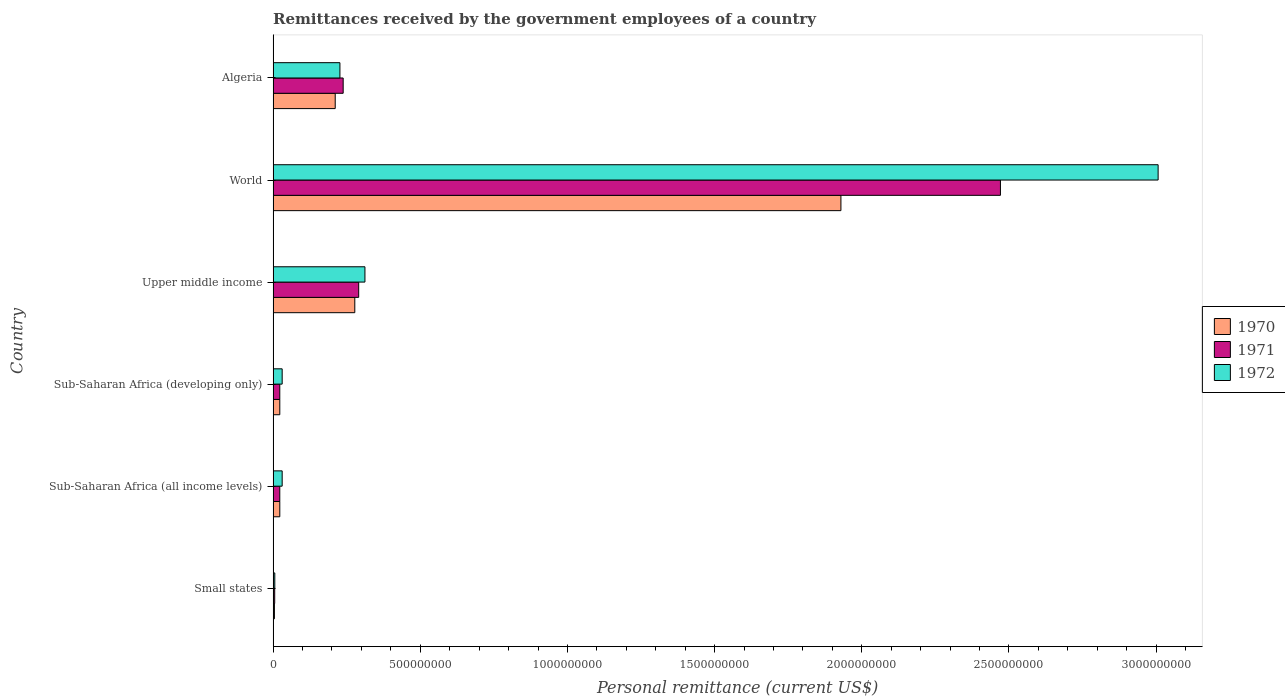How many different coloured bars are there?
Your response must be concise. 3. How many bars are there on the 5th tick from the top?
Provide a succinct answer. 3. What is the label of the 3rd group of bars from the top?
Your response must be concise. Upper middle income. In how many cases, is the number of bars for a given country not equal to the number of legend labels?
Your response must be concise. 0. What is the remittances received by the government employees in 1971 in Small states?
Keep it short and to the point. 5.40e+06. Across all countries, what is the maximum remittances received by the government employees in 1970?
Provide a succinct answer. 1.93e+09. Across all countries, what is the minimum remittances received by the government employees in 1972?
Ensure brevity in your answer.  5.71e+06. In which country was the remittances received by the government employees in 1971 minimum?
Offer a terse response. Small states. What is the total remittances received by the government employees in 1971 in the graph?
Offer a terse response. 3.05e+09. What is the difference between the remittances received by the government employees in 1970 in Algeria and that in World?
Your response must be concise. -1.72e+09. What is the difference between the remittances received by the government employees in 1970 in Algeria and the remittances received by the government employees in 1971 in Sub-Saharan Africa (all income levels)?
Ensure brevity in your answer.  1.88e+08. What is the average remittances received by the government employees in 1971 per country?
Your answer should be compact. 5.08e+08. What is the difference between the remittances received by the government employees in 1972 and remittances received by the government employees in 1970 in World?
Your response must be concise. 1.08e+09. What is the ratio of the remittances received by the government employees in 1970 in Sub-Saharan Africa (developing only) to that in World?
Make the answer very short. 0.01. What is the difference between the highest and the second highest remittances received by the government employees in 1971?
Provide a succinct answer. 2.18e+09. What is the difference between the highest and the lowest remittances received by the government employees in 1971?
Offer a very short reply. 2.47e+09. In how many countries, is the remittances received by the government employees in 1970 greater than the average remittances received by the government employees in 1970 taken over all countries?
Provide a succinct answer. 1. Is the sum of the remittances received by the government employees in 1972 in Sub-Saharan Africa (all income levels) and Upper middle income greater than the maximum remittances received by the government employees in 1971 across all countries?
Your answer should be compact. No. What does the 2nd bar from the bottom in Sub-Saharan Africa (all income levels) represents?
Keep it short and to the point. 1971. Is it the case that in every country, the sum of the remittances received by the government employees in 1971 and remittances received by the government employees in 1972 is greater than the remittances received by the government employees in 1970?
Keep it short and to the point. Yes. How many bars are there?
Provide a succinct answer. 18. Are all the bars in the graph horizontal?
Provide a succinct answer. Yes. What is the difference between two consecutive major ticks on the X-axis?
Make the answer very short. 5.00e+08. Does the graph contain any zero values?
Make the answer very short. No. Does the graph contain grids?
Ensure brevity in your answer.  No. Where does the legend appear in the graph?
Your response must be concise. Center right. How many legend labels are there?
Keep it short and to the point. 3. What is the title of the graph?
Ensure brevity in your answer.  Remittances received by the government employees of a country. What is the label or title of the X-axis?
Ensure brevity in your answer.  Personal remittance (current US$). What is the Personal remittance (current US$) in 1970 in Small states?
Offer a very short reply. 4.40e+06. What is the Personal remittance (current US$) in 1971 in Small states?
Make the answer very short. 5.40e+06. What is the Personal remittance (current US$) in 1972 in Small states?
Your response must be concise. 5.71e+06. What is the Personal remittance (current US$) of 1970 in Sub-Saharan Africa (all income levels)?
Keep it short and to the point. 2.27e+07. What is the Personal remittance (current US$) of 1971 in Sub-Saharan Africa (all income levels)?
Your response must be concise. 2.26e+07. What is the Personal remittance (current US$) of 1972 in Sub-Saharan Africa (all income levels)?
Your answer should be compact. 3.07e+07. What is the Personal remittance (current US$) in 1970 in Sub-Saharan Africa (developing only)?
Provide a succinct answer. 2.27e+07. What is the Personal remittance (current US$) of 1971 in Sub-Saharan Africa (developing only)?
Provide a succinct answer. 2.26e+07. What is the Personal remittance (current US$) in 1972 in Sub-Saharan Africa (developing only)?
Offer a very short reply. 3.07e+07. What is the Personal remittance (current US$) in 1970 in Upper middle income?
Provide a succinct answer. 2.77e+08. What is the Personal remittance (current US$) of 1971 in Upper middle income?
Ensure brevity in your answer.  2.91e+08. What is the Personal remittance (current US$) of 1972 in Upper middle income?
Your response must be concise. 3.12e+08. What is the Personal remittance (current US$) of 1970 in World?
Your answer should be compact. 1.93e+09. What is the Personal remittance (current US$) of 1971 in World?
Your answer should be very brief. 2.47e+09. What is the Personal remittance (current US$) in 1972 in World?
Make the answer very short. 3.01e+09. What is the Personal remittance (current US$) of 1970 in Algeria?
Keep it short and to the point. 2.11e+08. What is the Personal remittance (current US$) of 1971 in Algeria?
Offer a terse response. 2.38e+08. What is the Personal remittance (current US$) in 1972 in Algeria?
Provide a succinct answer. 2.27e+08. Across all countries, what is the maximum Personal remittance (current US$) of 1970?
Offer a terse response. 1.93e+09. Across all countries, what is the maximum Personal remittance (current US$) in 1971?
Your response must be concise. 2.47e+09. Across all countries, what is the maximum Personal remittance (current US$) of 1972?
Offer a terse response. 3.01e+09. Across all countries, what is the minimum Personal remittance (current US$) of 1970?
Offer a very short reply. 4.40e+06. Across all countries, what is the minimum Personal remittance (current US$) in 1971?
Keep it short and to the point. 5.40e+06. Across all countries, what is the minimum Personal remittance (current US$) in 1972?
Make the answer very short. 5.71e+06. What is the total Personal remittance (current US$) of 1970 in the graph?
Your answer should be very brief. 2.47e+09. What is the total Personal remittance (current US$) of 1971 in the graph?
Keep it short and to the point. 3.05e+09. What is the total Personal remittance (current US$) of 1972 in the graph?
Offer a very short reply. 3.61e+09. What is the difference between the Personal remittance (current US$) of 1970 in Small states and that in Sub-Saharan Africa (all income levels)?
Your answer should be compact. -1.83e+07. What is the difference between the Personal remittance (current US$) of 1971 in Small states and that in Sub-Saharan Africa (all income levels)?
Your answer should be very brief. -1.72e+07. What is the difference between the Personal remittance (current US$) in 1972 in Small states and that in Sub-Saharan Africa (all income levels)?
Offer a terse response. -2.50e+07. What is the difference between the Personal remittance (current US$) of 1970 in Small states and that in Sub-Saharan Africa (developing only)?
Give a very brief answer. -1.83e+07. What is the difference between the Personal remittance (current US$) in 1971 in Small states and that in Sub-Saharan Africa (developing only)?
Your response must be concise. -1.72e+07. What is the difference between the Personal remittance (current US$) of 1972 in Small states and that in Sub-Saharan Africa (developing only)?
Your answer should be very brief. -2.50e+07. What is the difference between the Personal remittance (current US$) in 1970 in Small states and that in Upper middle income?
Your response must be concise. -2.73e+08. What is the difference between the Personal remittance (current US$) of 1971 in Small states and that in Upper middle income?
Make the answer very short. -2.85e+08. What is the difference between the Personal remittance (current US$) in 1972 in Small states and that in Upper middle income?
Make the answer very short. -3.06e+08. What is the difference between the Personal remittance (current US$) of 1970 in Small states and that in World?
Make the answer very short. -1.92e+09. What is the difference between the Personal remittance (current US$) in 1971 in Small states and that in World?
Provide a succinct answer. -2.47e+09. What is the difference between the Personal remittance (current US$) of 1972 in Small states and that in World?
Keep it short and to the point. -3.00e+09. What is the difference between the Personal remittance (current US$) in 1970 in Small states and that in Algeria?
Your response must be concise. -2.07e+08. What is the difference between the Personal remittance (current US$) of 1971 in Small states and that in Algeria?
Offer a terse response. -2.33e+08. What is the difference between the Personal remittance (current US$) in 1972 in Small states and that in Algeria?
Make the answer very short. -2.21e+08. What is the difference between the Personal remittance (current US$) in 1971 in Sub-Saharan Africa (all income levels) and that in Sub-Saharan Africa (developing only)?
Make the answer very short. 0. What is the difference between the Personal remittance (current US$) in 1970 in Sub-Saharan Africa (all income levels) and that in Upper middle income?
Provide a short and direct response. -2.55e+08. What is the difference between the Personal remittance (current US$) in 1971 in Sub-Saharan Africa (all income levels) and that in Upper middle income?
Give a very brief answer. -2.68e+08. What is the difference between the Personal remittance (current US$) of 1972 in Sub-Saharan Africa (all income levels) and that in Upper middle income?
Make the answer very short. -2.81e+08. What is the difference between the Personal remittance (current US$) in 1970 in Sub-Saharan Africa (all income levels) and that in World?
Make the answer very short. -1.91e+09. What is the difference between the Personal remittance (current US$) of 1971 in Sub-Saharan Africa (all income levels) and that in World?
Your response must be concise. -2.45e+09. What is the difference between the Personal remittance (current US$) of 1972 in Sub-Saharan Africa (all income levels) and that in World?
Your answer should be very brief. -2.98e+09. What is the difference between the Personal remittance (current US$) of 1970 in Sub-Saharan Africa (all income levels) and that in Algeria?
Give a very brief answer. -1.88e+08. What is the difference between the Personal remittance (current US$) of 1971 in Sub-Saharan Africa (all income levels) and that in Algeria?
Offer a very short reply. -2.15e+08. What is the difference between the Personal remittance (current US$) of 1972 in Sub-Saharan Africa (all income levels) and that in Algeria?
Give a very brief answer. -1.96e+08. What is the difference between the Personal remittance (current US$) in 1970 in Sub-Saharan Africa (developing only) and that in Upper middle income?
Offer a terse response. -2.55e+08. What is the difference between the Personal remittance (current US$) in 1971 in Sub-Saharan Africa (developing only) and that in Upper middle income?
Provide a succinct answer. -2.68e+08. What is the difference between the Personal remittance (current US$) in 1972 in Sub-Saharan Africa (developing only) and that in Upper middle income?
Provide a succinct answer. -2.81e+08. What is the difference between the Personal remittance (current US$) in 1970 in Sub-Saharan Africa (developing only) and that in World?
Your answer should be very brief. -1.91e+09. What is the difference between the Personal remittance (current US$) of 1971 in Sub-Saharan Africa (developing only) and that in World?
Ensure brevity in your answer.  -2.45e+09. What is the difference between the Personal remittance (current US$) of 1972 in Sub-Saharan Africa (developing only) and that in World?
Provide a short and direct response. -2.98e+09. What is the difference between the Personal remittance (current US$) in 1970 in Sub-Saharan Africa (developing only) and that in Algeria?
Your answer should be compact. -1.88e+08. What is the difference between the Personal remittance (current US$) in 1971 in Sub-Saharan Africa (developing only) and that in Algeria?
Ensure brevity in your answer.  -2.15e+08. What is the difference between the Personal remittance (current US$) of 1972 in Sub-Saharan Africa (developing only) and that in Algeria?
Give a very brief answer. -1.96e+08. What is the difference between the Personal remittance (current US$) of 1970 in Upper middle income and that in World?
Offer a very short reply. -1.65e+09. What is the difference between the Personal remittance (current US$) in 1971 in Upper middle income and that in World?
Provide a succinct answer. -2.18e+09. What is the difference between the Personal remittance (current US$) in 1972 in Upper middle income and that in World?
Provide a succinct answer. -2.70e+09. What is the difference between the Personal remittance (current US$) of 1970 in Upper middle income and that in Algeria?
Your answer should be very brief. 6.65e+07. What is the difference between the Personal remittance (current US$) of 1971 in Upper middle income and that in Algeria?
Your answer should be very brief. 5.27e+07. What is the difference between the Personal remittance (current US$) of 1972 in Upper middle income and that in Algeria?
Give a very brief answer. 8.50e+07. What is the difference between the Personal remittance (current US$) in 1970 in World and that in Algeria?
Make the answer very short. 1.72e+09. What is the difference between the Personal remittance (current US$) in 1971 in World and that in Algeria?
Offer a very short reply. 2.23e+09. What is the difference between the Personal remittance (current US$) in 1972 in World and that in Algeria?
Keep it short and to the point. 2.78e+09. What is the difference between the Personal remittance (current US$) in 1970 in Small states and the Personal remittance (current US$) in 1971 in Sub-Saharan Africa (all income levels)?
Offer a very short reply. -1.82e+07. What is the difference between the Personal remittance (current US$) in 1970 in Small states and the Personal remittance (current US$) in 1972 in Sub-Saharan Africa (all income levels)?
Keep it short and to the point. -2.63e+07. What is the difference between the Personal remittance (current US$) in 1971 in Small states and the Personal remittance (current US$) in 1972 in Sub-Saharan Africa (all income levels)?
Provide a short and direct response. -2.53e+07. What is the difference between the Personal remittance (current US$) of 1970 in Small states and the Personal remittance (current US$) of 1971 in Sub-Saharan Africa (developing only)?
Your answer should be very brief. -1.82e+07. What is the difference between the Personal remittance (current US$) of 1970 in Small states and the Personal remittance (current US$) of 1972 in Sub-Saharan Africa (developing only)?
Your answer should be compact. -2.63e+07. What is the difference between the Personal remittance (current US$) in 1971 in Small states and the Personal remittance (current US$) in 1972 in Sub-Saharan Africa (developing only)?
Provide a succinct answer. -2.53e+07. What is the difference between the Personal remittance (current US$) in 1970 in Small states and the Personal remittance (current US$) in 1971 in Upper middle income?
Provide a short and direct response. -2.86e+08. What is the difference between the Personal remittance (current US$) in 1970 in Small states and the Personal remittance (current US$) in 1972 in Upper middle income?
Give a very brief answer. -3.08e+08. What is the difference between the Personal remittance (current US$) of 1971 in Small states and the Personal remittance (current US$) of 1972 in Upper middle income?
Offer a very short reply. -3.07e+08. What is the difference between the Personal remittance (current US$) of 1970 in Small states and the Personal remittance (current US$) of 1971 in World?
Make the answer very short. -2.47e+09. What is the difference between the Personal remittance (current US$) of 1970 in Small states and the Personal remittance (current US$) of 1972 in World?
Offer a terse response. -3.00e+09. What is the difference between the Personal remittance (current US$) in 1971 in Small states and the Personal remittance (current US$) in 1972 in World?
Ensure brevity in your answer.  -3.00e+09. What is the difference between the Personal remittance (current US$) of 1970 in Small states and the Personal remittance (current US$) of 1971 in Algeria?
Offer a terse response. -2.34e+08. What is the difference between the Personal remittance (current US$) of 1970 in Small states and the Personal remittance (current US$) of 1972 in Algeria?
Keep it short and to the point. -2.23e+08. What is the difference between the Personal remittance (current US$) in 1971 in Small states and the Personal remittance (current US$) in 1972 in Algeria?
Offer a terse response. -2.22e+08. What is the difference between the Personal remittance (current US$) of 1970 in Sub-Saharan Africa (all income levels) and the Personal remittance (current US$) of 1971 in Sub-Saharan Africa (developing only)?
Ensure brevity in your answer.  2.18e+04. What is the difference between the Personal remittance (current US$) in 1970 in Sub-Saharan Africa (all income levels) and the Personal remittance (current US$) in 1972 in Sub-Saharan Africa (developing only)?
Your response must be concise. -8.07e+06. What is the difference between the Personal remittance (current US$) of 1971 in Sub-Saharan Africa (all income levels) and the Personal remittance (current US$) of 1972 in Sub-Saharan Africa (developing only)?
Offer a terse response. -8.09e+06. What is the difference between the Personal remittance (current US$) of 1970 in Sub-Saharan Africa (all income levels) and the Personal remittance (current US$) of 1971 in Upper middle income?
Offer a terse response. -2.68e+08. What is the difference between the Personal remittance (current US$) in 1970 in Sub-Saharan Africa (all income levels) and the Personal remittance (current US$) in 1972 in Upper middle income?
Keep it short and to the point. -2.89e+08. What is the difference between the Personal remittance (current US$) of 1971 in Sub-Saharan Africa (all income levels) and the Personal remittance (current US$) of 1972 in Upper middle income?
Give a very brief answer. -2.89e+08. What is the difference between the Personal remittance (current US$) in 1970 in Sub-Saharan Africa (all income levels) and the Personal remittance (current US$) in 1971 in World?
Give a very brief answer. -2.45e+09. What is the difference between the Personal remittance (current US$) in 1970 in Sub-Saharan Africa (all income levels) and the Personal remittance (current US$) in 1972 in World?
Your response must be concise. -2.98e+09. What is the difference between the Personal remittance (current US$) in 1971 in Sub-Saharan Africa (all income levels) and the Personal remittance (current US$) in 1972 in World?
Provide a short and direct response. -2.98e+09. What is the difference between the Personal remittance (current US$) of 1970 in Sub-Saharan Africa (all income levels) and the Personal remittance (current US$) of 1971 in Algeria?
Offer a very short reply. -2.15e+08. What is the difference between the Personal remittance (current US$) in 1970 in Sub-Saharan Africa (all income levels) and the Personal remittance (current US$) in 1972 in Algeria?
Ensure brevity in your answer.  -2.04e+08. What is the difference between the Personal remittance (current US$) of 1971 in Sub-Saharan Africa (all income levels) and the Personal remittance (current US$) of 1972 in Algeria?
Provide a succinct answer. -2.04e+08. What is the difference between the Personal remittance (current US$) of 1970 in Sub-Saharan Africa (developing only) and the Personal remittance (current US$) of 1971 in Upper middle income?
Keep it short and to the point. -2.68e+08. What is the difference between the Personal remittance (current US$) in 1970 in Sub-Saharan Africa (developing only) and the Personal remittance (current US$) in 1972 in Upper middle income?
Your answer should be compact. -2.89e+08. What is the difference between the Personal remittance (current US$) of 1971 in Sub-Saharan Africa (developing only) and the Personal remittance (current US$) of 1972 in Upper middle income?
Ensure brevity in your answer.  -2.89e+08. What is the difference between the Personal remittance (current US$) of 1970 in Sub-Saharan Africa (developing only) and the Personal remittance (current US$) of 1971 in World?
Your answer should be compact. -2.45e+09. What is the difference between the Personal remittance (current US$) in 1970 in Sub-Saharan Africa (developing only) and the Personal remittance (current US$) in 1972 in World?
Offer a very short reply. -2.98e+09. What is the difference between the Personal remittance (current US$) in 1971 in Sub-Saharan Africa (developing only) and the Personal remittance (current US$) in 1972 in World?
Ensure brevity in your answer.  -2.98e+09. What is the difference between the Personal remittance (current US$) of 1970 in Sub-Saharan Africa (developing only) and the Personal remittance (current US$) of 1971 in Algeria?
Ensure brevity in your answer.  -2.15e+08. What is the difference between the Personal remittance (current US$) of 1970 in Sub-Saharan Africa (developing only) and the Personal remittance (current US$) of 1972 in Algeria?
Provide a succinct answer. -2.04e+08. What is the difference between the Personal remittance (current US$) of 1971 in Sub-Saharan Africa (developing only) and the Personal remittance (current US$) of 1972 in Algeria?
Make the answer very short. -2.04e+08. What is the difference between the Personal remittance (current US$) in 1970 in Upper middle income and the Personal remittance (current US$) in 1971 in World?
Give a very brief answer. -2.19e+09. What is the difference between the Personal remittance (current US$) in 1970 in Upper middle income and the Personal remittance (current US$) in 1972 in World?
Provide a short and direct response. -2.73e+09. What is the difference between the Personal remittance (current US$) of 1971 in Upper middle income and the Personal remittance (current US$) of 1972 in World?
Offer a very short reply. -2.72e+09. What is the difference between the Personal remittance (current US$) in 1970 in Upper middle income and the Personal remittance (current US$) in 1971 in Algeria?
Ensure brevity in your answer.  3.95e+07. What is the difference between the Personal remittance (current US$) of 1970 in Upper middle income and the Personal remittance (current US$) of 1972 in Algeria?
Keep it short and to the point. 5.05e+07. What is the difference between the Personal remittance (current US$) in 1971 in Upper middle income and the Personal remittance (current US$) in 1972 in Algeria?
Make the answer very short. 6.37e+07. What is the difference between the Personal remittance (current US$) in 1970 in World and the Personal remittance (current US$) in 1971 in Algeria?
Your answer should be very brief. 1.69e+09. What is the difference between the Personal remittance (current US$) of 1970 in World and the Personal remittance (current US$) of 1972 in Algeria?
Make the answer very short. 1.70e+09. What is the difference between the Personal remittance (current US$) of 1971 in World and the Personal remittance (current US$) of 1972 in Algeria?
Your answer should be compact. 2.24e+09. What is the average Personal remittance (current US$) in 1970 per country?
Offer a very short reply. 4.11e+08. What is the average Personal remittance (current US$) of 1971 per country?
Provide a short and direct response. 5.08e+08. What is the average Personal remittance (current US$) in 1972 per country?
Keep it short and to the point. 6.02e+08. What is the difference between the Personal remittance (current US$) of 1970 and Personal remittance (current US$) of 1971 in Small states?
Give a very brief answer. -1.00e+06. What is the difference between the Personal remittance (current US$) of 1970 and Personal remittance (current US$) of 1972 in Small states?
Give a very brief answer. -1.31e+06. What is the difference between the Personal remittance (current US$) of 1971 and Personal remittance (current US$) of 1972 in Small states?
Ensure brevity in your answer.  -3.07e+05. What is the difference between the Personal remittance (current US$) of 1970 and Personal remittance (current US$) of 1971 in Sub-Saharan Africa (all income levels)?
Ensure brevity in your answer.  2.18e+04. What is the difference between the Personal remittance (current US$) of 1970 and Personal remittance (current US$) of 1972 in Sub-Saharan Africa (all income levels)?
Your answer should be very brief. -8.07e+06. What is the difference between the Personal remittance (current US$) of 1971 and Personal remittance (current US$) of 1972 in Sub-Saharan Africa (all income levels)?
Provide a short and direct response. -8.09e+06. What is the difference between the Personal remittance (current US$) of 1970 and Personal remittance (current US$) of 1971 in Sub-Saharan Africa (developing only)?
Give a very brief answer. 2.18e+04. What is the difference between the Personal remittance (current US$) of 1970 and Personal remittance (current US$) of 1972 in Sub-Saharan Africa (developing only)?
Provide a short and direct response. -8.07e+06. What is the difference between the Personal remittance (current US$) of 1971 and Personal remittance (current US$) of 1972 in Sub-Saharan Africa (developing only)?
Your response must be concise. -8.09e+06. What is the difference between the Personal remittance (current US$) of 1970 and Personal remittance (current US$) of 1971 in Upper middle income?
Ensure brevity in your answer.  -1.32e+07. What is the difference between the Personal remittance (current US$) in 1970 and Personal remittance (current US$) in 1972 in Upper middle income?
Make the answer very short. -3.45e+07. What is the difference between the Personal remittance (current US$) in 1971 and Personal remittance (current US$) in 1972 in Upper middle income?
Provide a succinct answer. -2.13e+07. What is the difference between the Personal remittance (current US$) in 1970 and Personal remittance (current US$) in 1971 in World?
Your answer should be compact. -5.42e+08. What is the difference between the Personal remittance (current US$) in 1970 and Personal remittance (current US$) in 1972 in World?
Your answer should be compact. -1.08e+09. What is the difference between the Personal remittance (current US$) of 1971 and Personal remittance (current US$) of 1972 in World?
Your response must be concise. -5.36e+08. What is the difference between the Personal remittance (current US$) of 1970 and Personal remittance (current US$) of 1971 in Algeria?
Your answer should be compact. -2.70e+07. What is the difference between the Personal remittance (current US$) of 1970 and Personal remittance (current US$) of 1972 in Algeria?
Provide a short and direct response. -1.60e+07. What is the difference between the Personal remittance (current US$) of 1971 and Personal remittance (current US$) of 1972 in Algeria?
Your answer should be very brief. 1.10e+07. What is the ratio of the Personal remittance (current US$) in 1970 in Small states to that in Sub-Saharan Africa (all income levels)?
Provide a succinct answer. 0.19. What is the ratio of the Personal remittance (current US$) in 1971 in Small states to that in Sub-Saharan Africa (all income levels)?
Keep it short and to the point. 0.24. What is the ratio of the Personal remittance (current US$) of 1972 in Small states to that in Sub-Saharan Africa (all income levels)?
Your response must be concise. 0.19. What is the ratio of the Personal remittance (current US$) in 1970 in Small states to that in Sub-Saharan Africa (developing only)?
Ensure brevity in your answer.  0.19. What is the ratio of the Personal remittance (current US$) in 1971 in Small states to that in Sub-Saharan Africa (developing only)?
Your answer should be very brief. 0.24. What is the ratio of the Personal remittance (current US$) in 1972 in Small states to that in Sub-Saharan Africa (developing only)?
Your answer should be compact. 0.19. What is the ratio of the Personal remittance (current US$) of 1970 in Small states to that in Upper middle income?
Keep it short and to the point. 0.02. What is the ratio of the Personal remittance (current US$) in 1971 in Small states to that in Upper middle income?
Your response must be concise. 0.02. What is the ratio of the Personal remittance (current US$) of 1972 in Small states to that in Upper middle income?
Provide a succinct answer. 0.02. What is the ratio of the Personal remittance (current US$) in 1970 in Small states to that in World?
Make the answer very short. 0. What is the ratio of the Personal remittance (current US$) in 1971 in Small states to that in World?
Offer a terse response. 0. What is the ratio of the Personal remittance (current US$) of 1972 in Small states to that in World?
Make the answer very short. 0. What is the ratio of the Personal remittance (current US$) in 1970 in Small states to that in Algeria?
Provide a short and direct response. 0.02. What is the ratio of the Personal remittance (current US$) in 1971 in Small states to that in Algeria?
Keep it short and to the point. 0.02. What is the ratio of the Personal remittance (current US$) in 1972 in Small states to that in Algeria?
Give a very brief answer. 0.03. What is the ratio of the Personal remittance (current US$) in 1970 in Sub-Saharan Africa (all income levels) to that in Sub-Saharan Africa (developing only)?
Your answer should be compact. 1. What is the ratio of the Personal remittance (current US$) of 1971 in Sub-Saharan Africa (all income levels) to that in Sub-Saharan Africa (developing only)?
Provide a succinct answer. 1. What is the ratio of the Personal remittance (current US$) of 1972 in Sub-Saharan Africa (all income levels) to that in Sub-Saharan Africa (developing only)?
Your answer should be compact. 1. What is the ratio of the Personal remittance (current US$) in 1970 in Sub-Saharan Africa (all income levels) to that in Upper middle income?
Give a very brief answer. 0.08. What is the ratio of the Personal remittance (current US$) in 1971 in Sub-Saharan Africa (all income levels) to that in Upper middle income?
Provide a succinct answer. 0.08. What is the ratio of the Personal remittance (current US$) in 1972 in Sub-Saharan Africa (all income levels) to that in Upper middle income?
Your response must be concise. 0.1. What is the ratio of the Personal remittance (current US$) of 1970 in Sub-Saharan Africa (all income levels) to that in World?
Make the answer very short. 0.01. What is the ratio of the Personal remittance (current US$) of 1971 in Sub-Saharan Africa (all income levels) to that in World?
Ensure brevity in your answer.  0.01. What is the ratio of the Personal remittance (current US$) of 1972 in Sub-Saharan Africa (all income levels) to that in World?
Your response must be concise. 0.01. What is the ratio of the Personal remittance (current US$) in 1970 in Sub-Saharan Africa (all income levels) to that in Algeria?
Your response must be concise. 0.11. What is the ratio of the Personal remittance (current US$) in 1971 in Sub-Saharan Africa (all income levels) to that in Algeria?
Keep it short and to the point. 0.1. What is the ratio of the Personal remittance (current US$) in 1972 in Sub-Saharan Africa (all income levels) to that in Algeria?
Provide a succinct answer. 0.14. What is the ratio of the Personal remittance (current US$) of 1970 in Sub-Saharan Africa (developing only) to that in Upper middle income?
Offer a very short reply. 0.08. What is the ratio of the Personal remittance (current US$) in 1971 in Sub-Saharan Africa (developing only) to that in Upper middle income?
Ensure brevity in your answer.  0.08. What is the ratio of the Personal remittance (current US$) of 1972 in Sub-Saharan Africa (developing only) to that in Upper middle income?
Provide a succinct answer. 0.1. What is the ratio of the Personal remittance (current US$) in 1970 in Sub-Saharan Africa (developing only) to that in World?
Give a very brief answer. 0.01. What is the ratio of the Personal remittance (current US$) in 1971 in Sub-Saharan Africa (developing only) to that in World?
Provide a succinct answer. 0.01. What is the ratio of the Personal remittance (current US$) of 1972 in Sub-Saharan Africa (developing only) to that in World?
Make the answer very short. 0.01. What is the ratio of the Personal remittance (current US$) in 1970 in Sub-Saharan Africa (developing only) to that in Algeria?
Provide a short and direct response. 0.11. What is the ratio of the Personal remittance (current US$) in 1971 in Sub-Saharan Africa (developing only) to that in Algeria?
Your answer should be compact. 0.1. What is the ratio of the Personal remittance (current US$) of 1972 in Sub-Saharan Africa (developing only) to that in Algeria?
Your response must be concise. 0.14. What is the ratio of the Personal remittance (current US$) in 1970 in Upper middle income to that in World?
Provide a succinct answer. 0.14. What is the ratio of the Personal remittance (current US$) in 1971 in Upper middle income to that in World?
Provide a succinct answer. 0.12. What is the ratio of the Personal remittance (current US$) of 1972 in Upper middle income to that in World?
Provide a succinct answer. 0.1. What is the ratio of the Personal remittance (current US$) in 1970 in Upper middle income to that in Algeria?
Ensure brevity in your answer.  1.32. What is the ratio of the Personal remittance (current US$) in 1971 in Upper middle income to that in Algeria?
Your response must be concise. 1.22. What is the ratio of the Personal remittance (current US$) of 1972 in Upper middle income to that in Algeria?
Offer a terse response. 1.37. What is the ratio of the Personal remittance (current US$) of 1970 in World to that in Algeria?
Provide a succinct answer. 9.14. What is the ratio of the Personal remittance (current US$) in 1971 in World to that in Algeria?
Keep it short and to the point. 10.38. What is the ratio of the Personal remittance (current US$) of 1972 in World to that in Algeria?
Ensure brevity in your answer.  13.25. What is the difference between the highest and the second highest Personal remittance (current US$) in 1970?
Your response must be concise. 1.65e+09. What is the difference between the highest and the second highest Personal remittance (current US$) in 1971?
Give a very brief answer. 2.18e+09. What is the difference between the highest and the second highest Personal remittance (current US$) of 1972?
Your response must be concise. 2.70e+09. What is the difference between the highest and the lowest Personal remittance (current US$) of 1970?
Keep it short and to the point. 1.92e+09. What is the difference between the highest and the lowest Personal remittance (current US$) in 1971?
Offer a terse response. 2.47e+09. What is the difference between the highest and the lowest Personal remittance (current US$) of 1972?
Your answer should be very brief. 3.00e+09. 